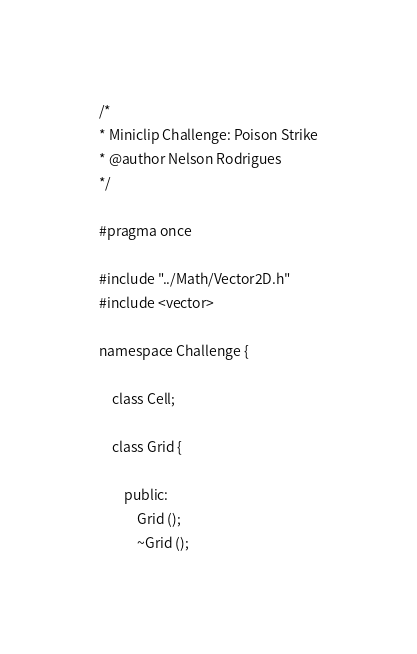Convert code to text. <code><loc_0><loc_0><loc_500><loc_500><_C_>/* 
* Miniclip Challenge: Poison Strike
* @author Nelson Rodrigues
*/

#pragma once

#include "../Math/Vector2D.h"
#include <vector>

namespace Challenge {
	
	class Cell;
	
	class Grid {

		public:
			Grid ();
			~Grid ();
</code> 